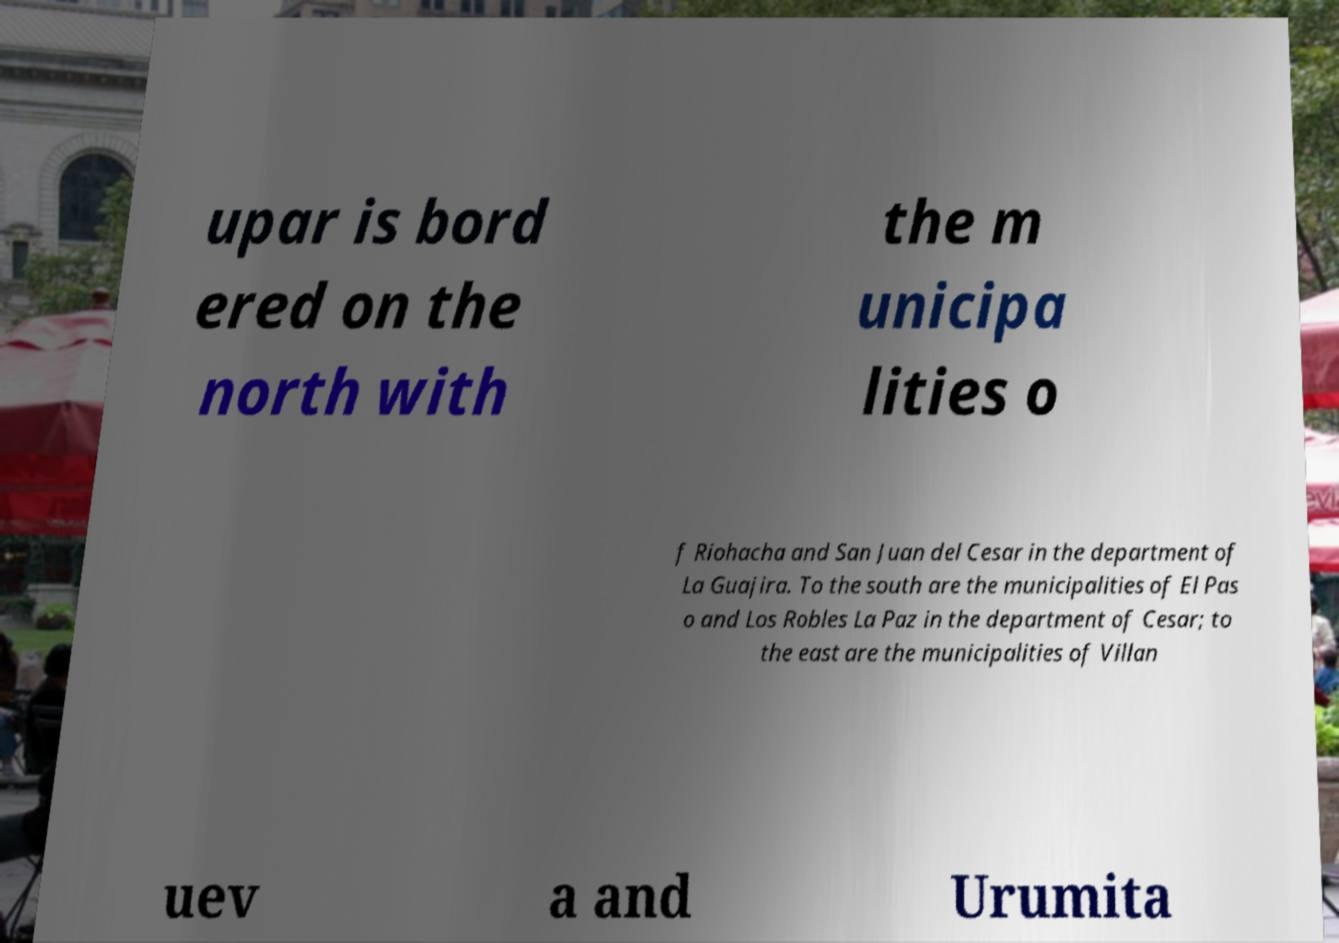There's text embedded in this image that I need extracted. Can you transcribe it verbatim? upar is bord ered on the north with the m unicipa lities o f Riohacha and San Juan del Cesar in the department of La Guajira. To the south are the municipalities of El Pas o and Los Robles La Paz in the department of Cesar; to the east are the municipalities of Villan uev a and Urumita 